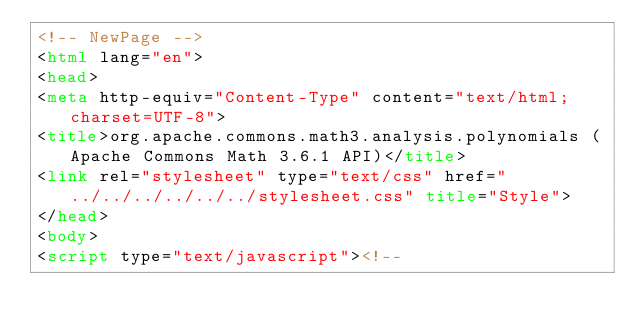Convert code to text. <code><loc_0><loc_0><loc_500><loc_500><_HTML_><!-- NewPage -->
<html lang="en">
<head>
<meta http-equiv="Content-Type" content="text/html; charset=UTF-8">
<title>org.apache.commons.math3.analysis.polynomials (Apache Commons Math 3.6.1 API)</title>
<link rel="stylesheet" type="text/css" href="../../../../../../stylesheet.css" title="Style">
</head>
<body>
<script type="text/javascript"><!--</code> 